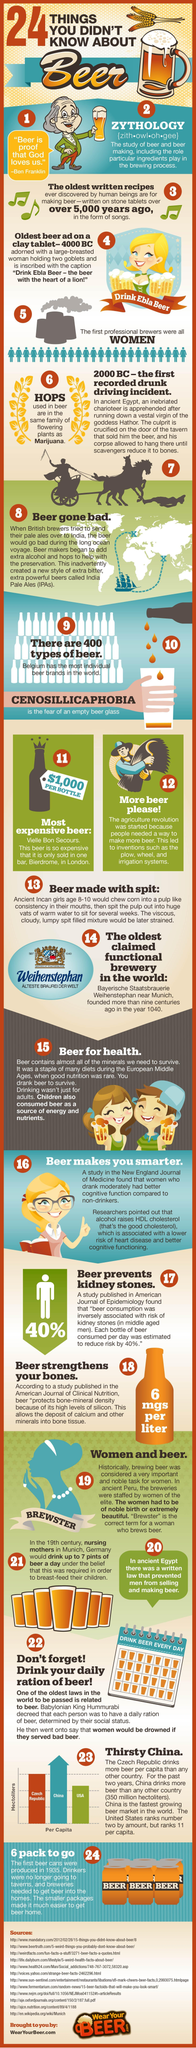Which is the plant used for making beer?
Answer the question with a short phrase. Hops In which country it was believed that drinking beer helps in breast feeding? Munich, Germany A women who drinks beer is called? Brewster What is the study of beer called? Zythology 